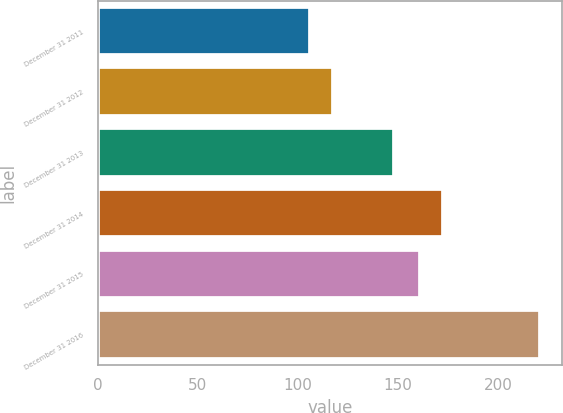<chart> <loc_0><loc_0><loc_500><loc_500><bar_chart><fcel>December 31 2011<fcel>December 31 2012<fcel>December 31 2013<fcel>December 31 2014<fcel>December 31 2015<fcel>December 31 2016<nl><fcel>106<fcel>117.5<fcel>148<fcel>172.5<fcel>161<fcel>221<nl></chart> 